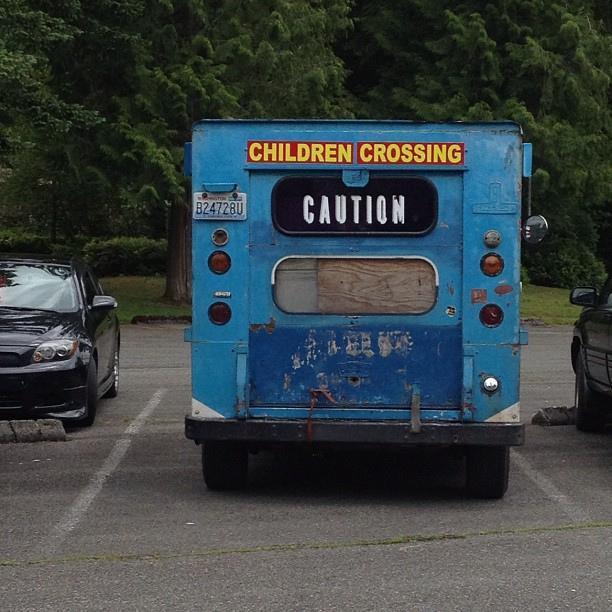How many arrows do you see in this picture?
Give a very brief answer. 0. How many cars are in the picture?
Give a very brief answer. 2. 